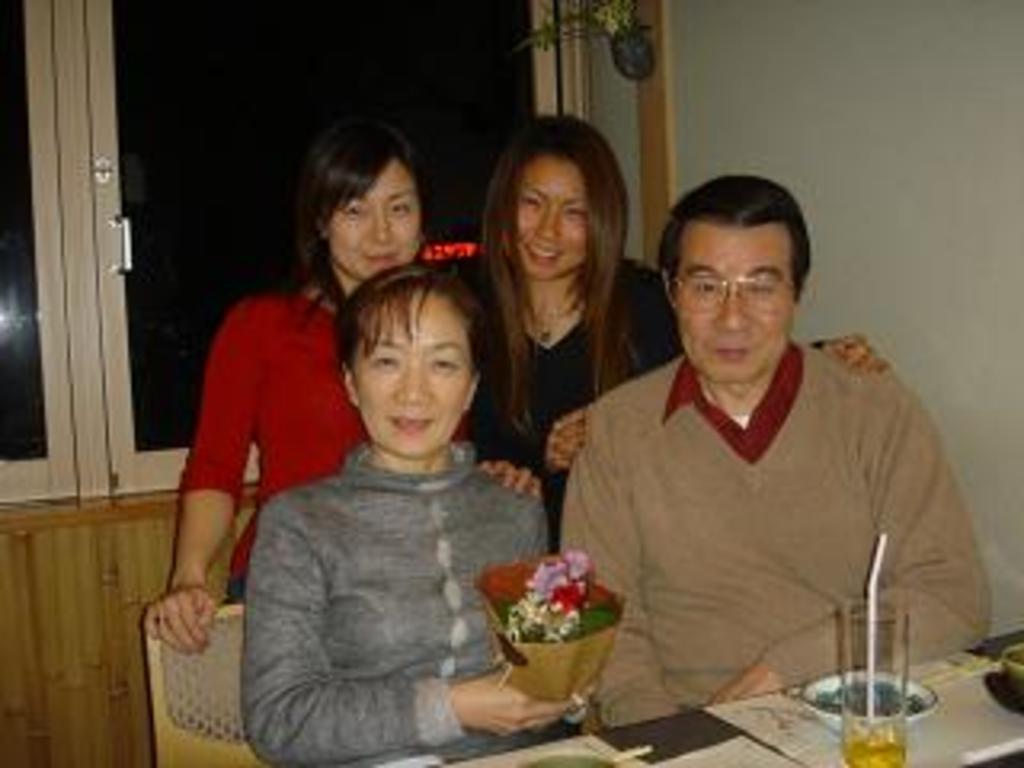Describe this image in one or two sentences. In this image there is a couple sitting on chairs, the woman is holding a flower bouquet in her hand, in front of them there is a plate and a glass of drink on the table, behind them there are two women standing with a smile on their face, behind them there is a glass window. 